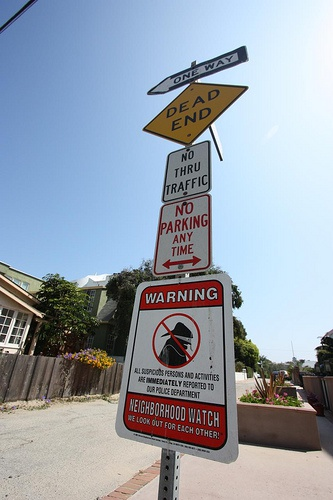Describe the objects in this image and their specific colors. I can see various objects in this image with different colors. 